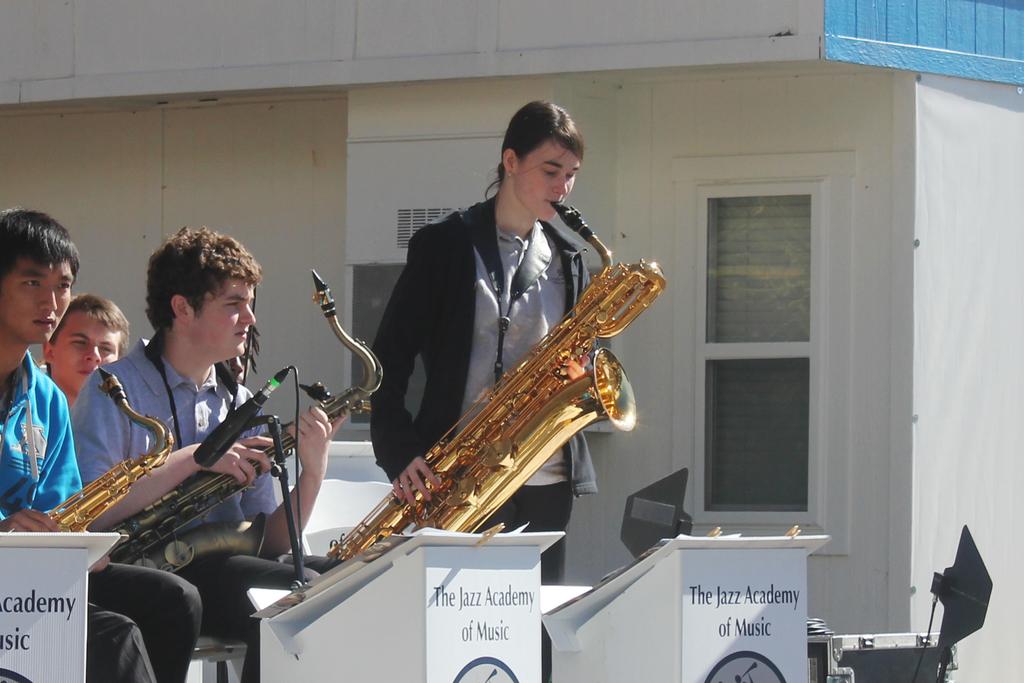What school does this band play for?
Keep it short and to the point. The jazz academy of music. What genre does the academy of music represent?
Make the answer very short. Jazz. 